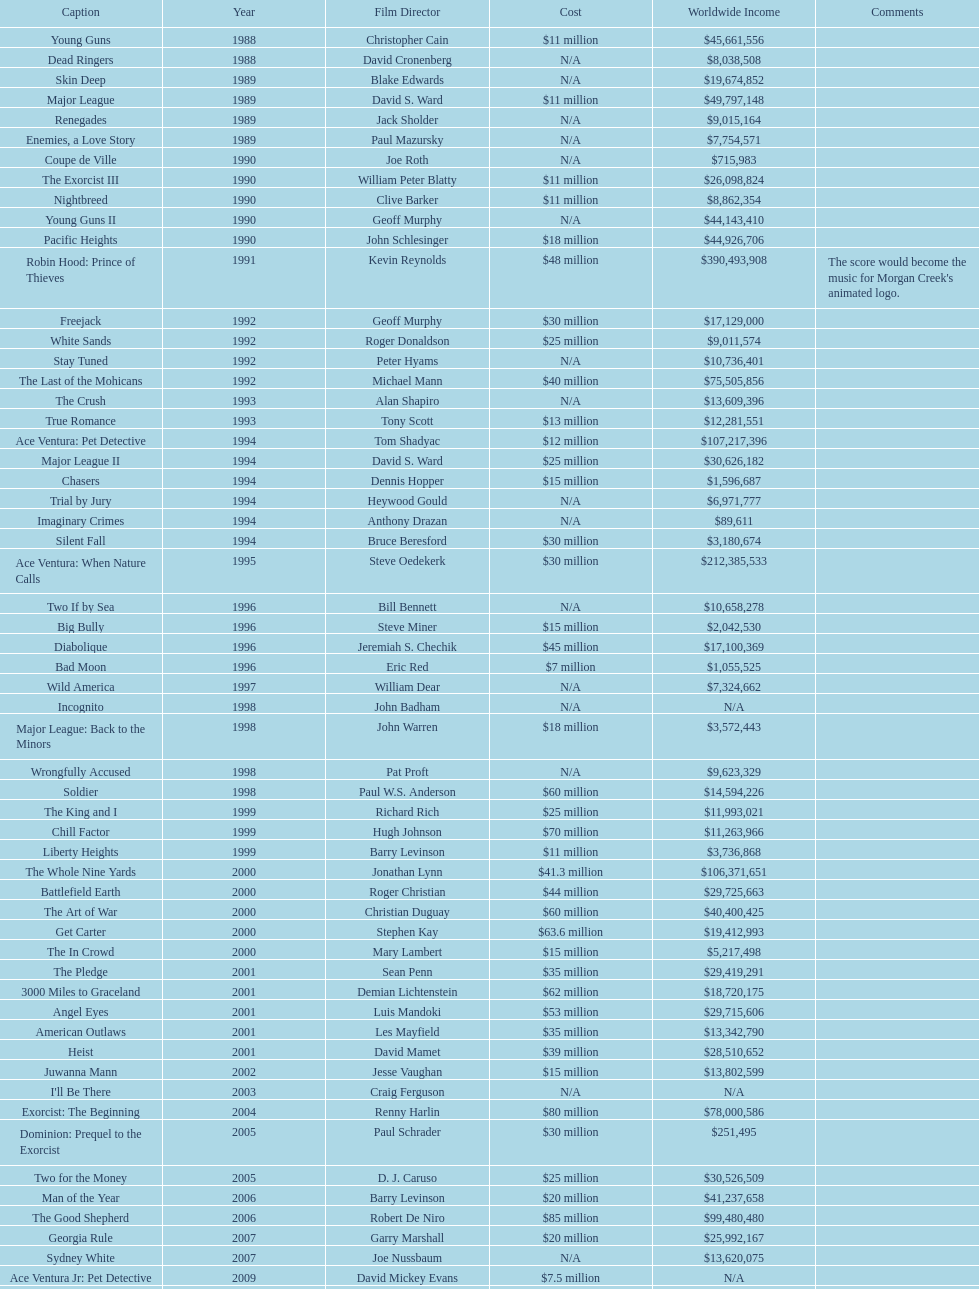Which movie holds the highest-grossing record? Robin Hood: Prince of Thieves. 